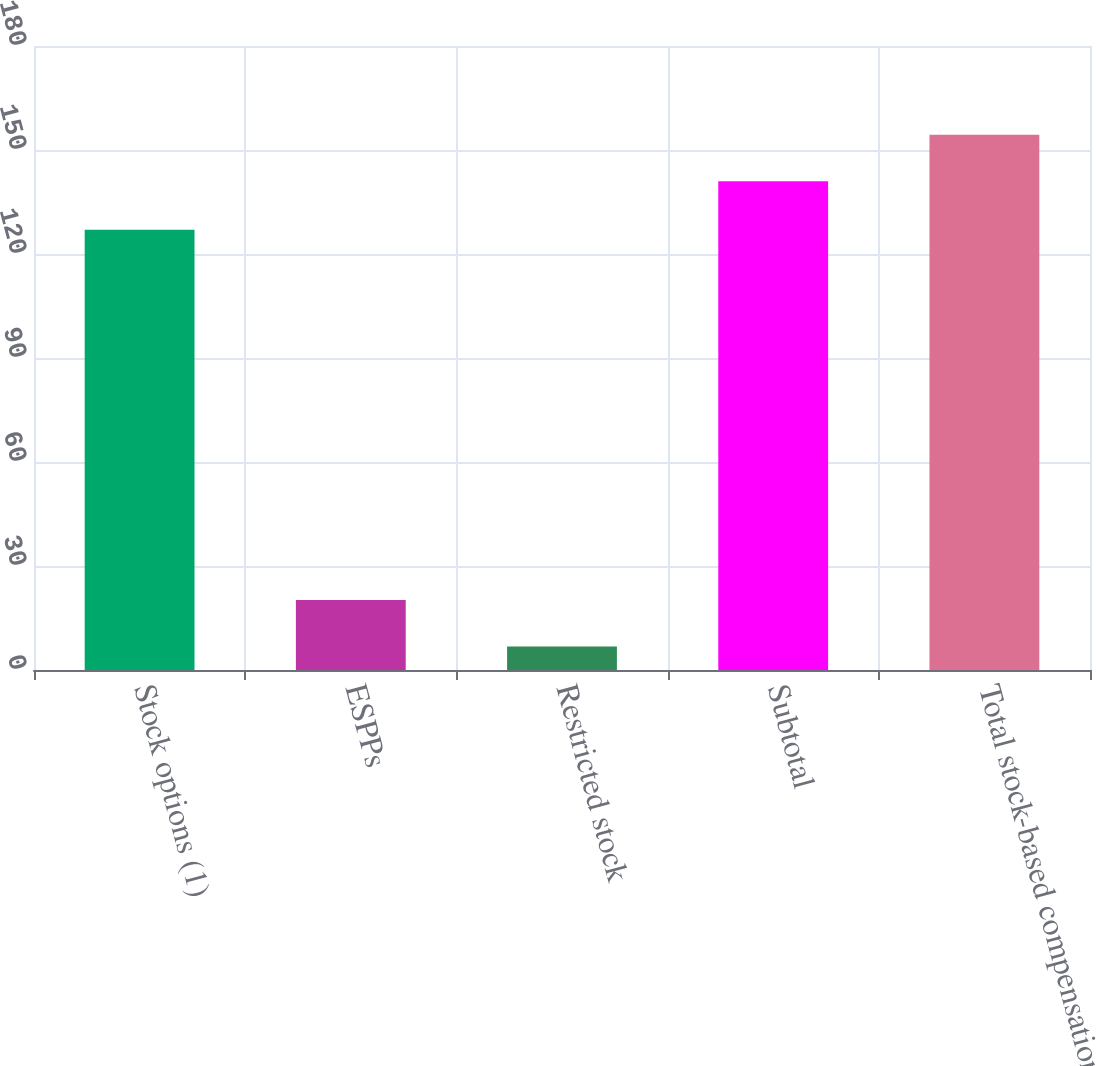Convert chart. <chart><loc_0><loc_0><loc_500><loc_500><bar_chart><fcel>Stock options (1)<fcel>ESPPs<fcel>Restricted stock<fcel>Subtotal<fcel>Total stock-based compensation<nl><fcel>127<fcel>20.22<fcel>6.8<fcel>141<fcel>154.42<nl></chart> 